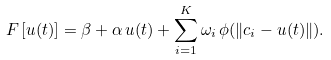<formula> <loc_0><loc_0><loc_500><loc_500>F \left [ u ( t ) \right ] = \beta + \alpha \, u ( t ) + \sum _ { i = 1 } ^ { K } \omega _ { i } \, \phi ( \| c _ { i } - u ( t ) \| ) .</formula> 